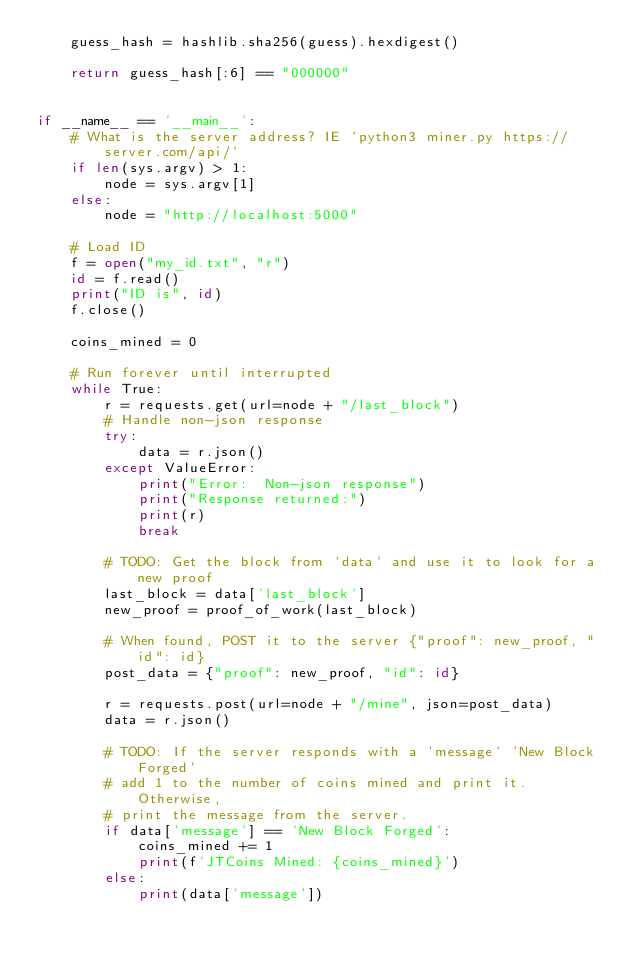<code> <loc_0><loc_0><loc_500><loc_500><_Python_>    guess_hash = hashlib.sha256(guess).hexdigest()

    return guess_hash[:6] == "000000"


if __name__ == '__main__':
    # What is the server address? IE `python3 miner.py https://server.com/api/`
    if len(sys.argv) > 1:
        node = sys.argv[1]
    else:
        node = "http://localhost:5000"

    # Load ID
    f = open("my_id.txt", "r")
    id = f.read()
    print("ID is", id)
    f.close()

    coins_mined = 0

    # Run forever until interrupted
    while True:
        r = requests.get(url=node + "/last_block")
        # Handle non-json response
        try:
            data = r.json()
        except ValueError:
            print("Error:  Non-json response")
            print("Response returned:")
            print(r)
            break

        # TODO: Get the block from `data` and use it to look for a new proof
        last_block = data['last_block']
        new_proof = proof_of_work(last_block)

        # When found, POST it to the server {"proof": new_proof, "id": id}
        post_data = {"proof": new_proof, "id": id}

        r = requests.post(url=node + "/mine", json=post_data)
        data = r.json()

        # TODO: If the server responds with a 'message' 'New Block Forged'
        # add 1 to the number of coins mined and print it.  Otherwise,
        # print the message from the server.
        if data['message'] == 'New Block Forged':
            coins_mined += 1
            print(f'JTCoins Mined: {coins_mined}')
        else:
            print(data['message'])
</code> 